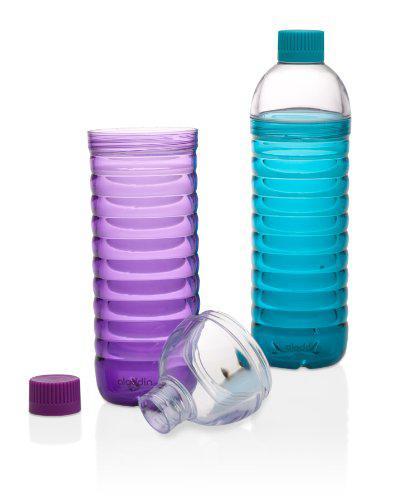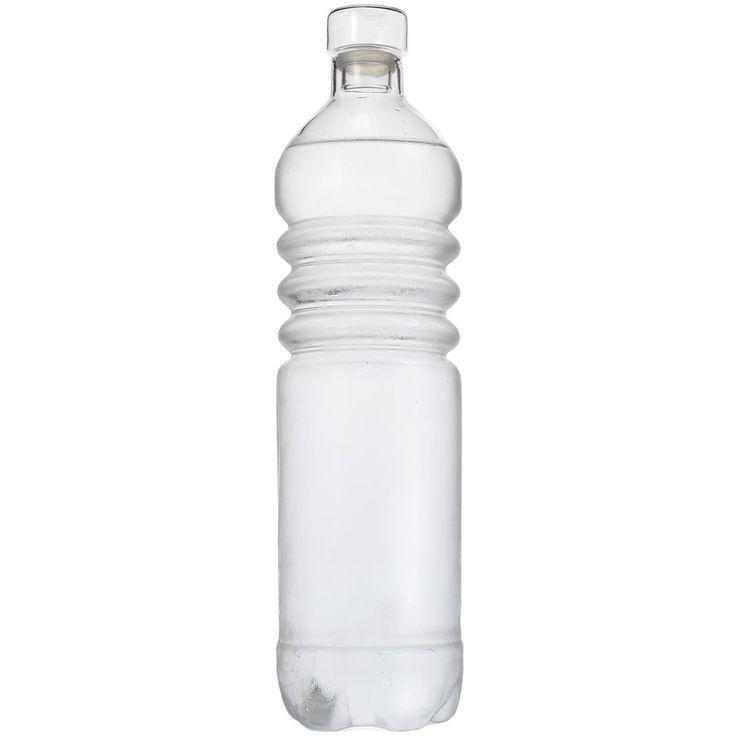The first image is the image on the left, the second image is the image on the right. Given the left and right images, does the statement "An image includes a clear water bottle with exactly three ribbed bands around its upper midsection." hold true? Answer yes or no. Yes. The first image is the image on the left, the second image is the image on the right. Analyze the images presented: Is the assertion "There are more than three bottles." valid? Answer yes or no. No. 